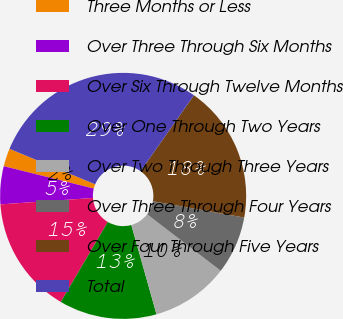<chart> <loc_0><loc_0><loc_500><loc_500><pie_chart><fcel>Three Months or Less<fcel>Over Three Through Six Months<fcel>Over Six Through Twelve Months<fcel>Over One Through Two Years<fcel>Over Two Through Three Years<fcel>Over Three Through Four Years<fcel>Over Four Through Five Years<fcel>Total<nl><fcel>2.37%<fcel>4.98%<fcel>15.44%<fcel>12.83%<fcel>10.21%<fcel>7.6%<fcel>18.06%<fcel>28.51%<nl></chart> 